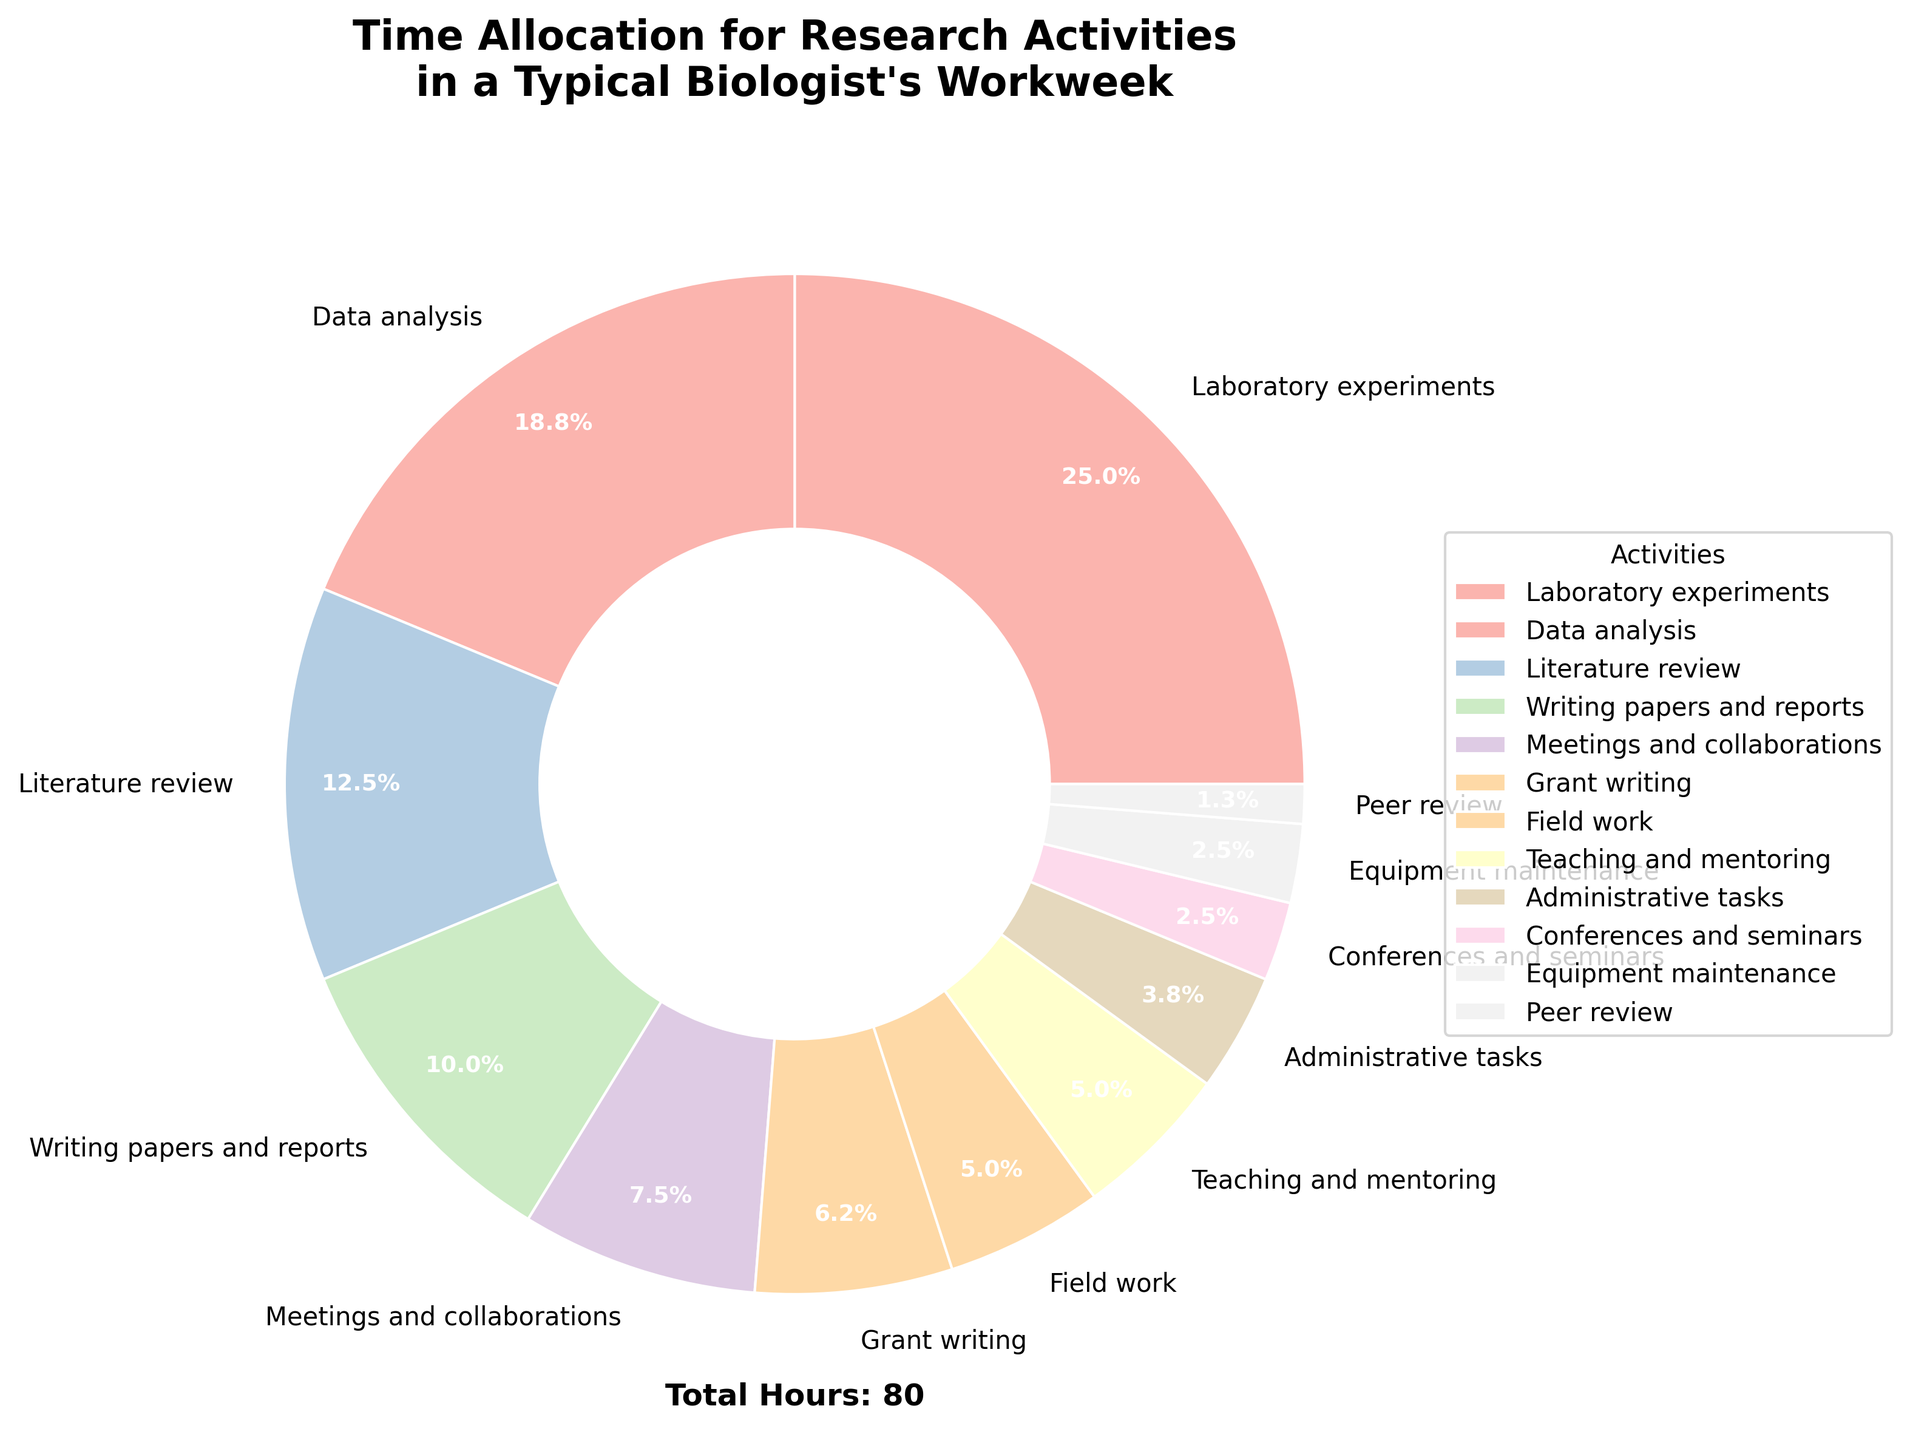What activity takes up the most hours? Locate the activity with the largest pie slice. Based on the data, "Laboratory experiments" has the highest percentage.
Answer: Laboratory experiments Which activities take up the least amount of hours, and what are their total hours combined? Identify activities with the smallest pie slices. "Peer review" and "Equipment maintenance" have the smallest slices. Sum their hours: 1 + 2 = 3 hours.
Answer: Peer review and Equipment maintenance, 3 hours Is the time spent on writing papers and reports greater than the time spent on meetings and collaborations? Compare the pie slices for "Writing papers and reports" and "Meetings and collaborations." "Writing papers and reports" has 8 hours, and "Meetings and collaborations" has 6 hours, so 8 > 6.
Answer: Yes How much of the time is dedicated to literature review and data analysis combined? Sum the hours associated with "Literature review" and "Data analysis." 10 + 15 = 25 hours.
Answer: 25 hours How does the time allocation for teaching and mentoring compare to field work? Compare the sizes of the pie slices for "Teaching and mentoring" and "Field work". Both have the same slice size; each activity has 4 hours.
Answer: Equal, 4 hours each What is the total percentage of time spent on administrative tasks, conferences and seminars, and equipment maintenance combined? Calculate the individual percentages and sum them. Administrative tasks (3%), Conferences and seminars (2%), Equipment maintenance (2%). Combined, 3% + 2% + 2% = 7%.
Answer: 7% Which activity has a pie slice with a width of 0.5? All activities have pie slices with a width of 0.5 because of the wedgeprops parameter in the plot function. The question asks about a specific visual property applied to all slices.
Answer: All activities What is the fraction of time allocated to teaching and mentoring out of the total workweek hours? Divide the hours for "Teaching and mentoring" by the total hours. 4 / (20+15+10+8+6+5+4+4+3+2+2+1) = 4 / 80 = 1/20.
Answer: 1/20 If we grouped "Literature review" and "Writing papers and reports" together as a new category, what percentage of the workweek would this new category represent? Calculate the combined hours for the new category and convert to a percentage of the total hours. (10 + 8)/80 = 18/80 = 22.5%.
Answer: 22.5% Do laboratory experiments occupy more than double the hours spent on grant writing? Check if hours for "Laboratory experiments" are more than twice the hours for "Grant writing." 20 hours vs. 2*5 hours: 20 > 10.
Answer: Yes 